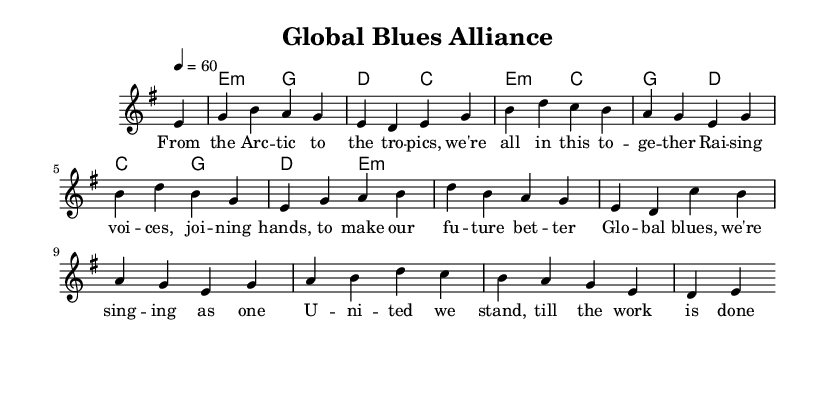What is the key signature of this music? The key signature is E minor, indicated by one sharp (F#).
Answer: E minor What is the time signature of this piece? The time signature is 4/4, which means there are four beats per measure.
Answer: 4/4 What is the tempo marking for this music? The tempo is marked at 60 beats per minute, which is a moderate pace.
Answer: 60 How many verses are there in this song? The song has one verse followed by a chorus, making it a single verse structure.
Answer: One What is the first note of the melody? The first note shown in the melody staff is E, which starts the piece off.
Answer: E What is the chord progression in the first measure? The first measure has no chord; it starts with a rest (4 eighths) before moving to a minor chord in the second measure.
Answer: Rest What lyrics are associated with the chorus? The chorus lyrics emphasize unity, indicating strength through cooperation, thus highlighting the theme of togetherness.
Answer: Global blues, we're singing as one 